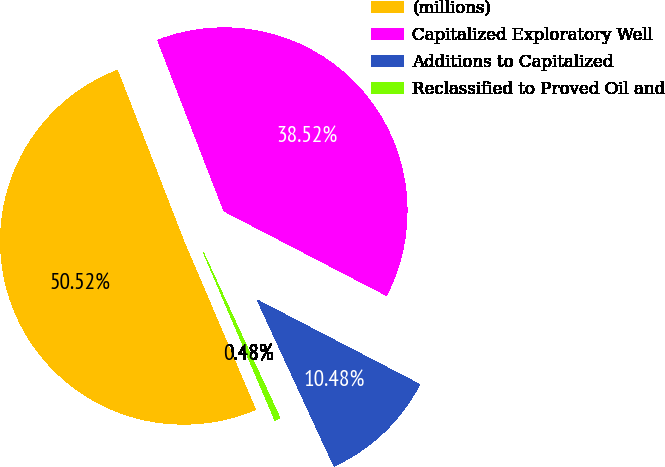Convert chart to OTSL. <chart><loc_0><loc_0><loc_500><loc_500><pie_chart><fcel>(millions)<fcel>Capitalized Exploratory Well<fcel>Additions to Capitalized<fcel>Reclassified to Proved Oil and<nl><fcel>50.52%<fcel>38.52%<fcel>10.48%<fcel>0.48%<nl></chart> 